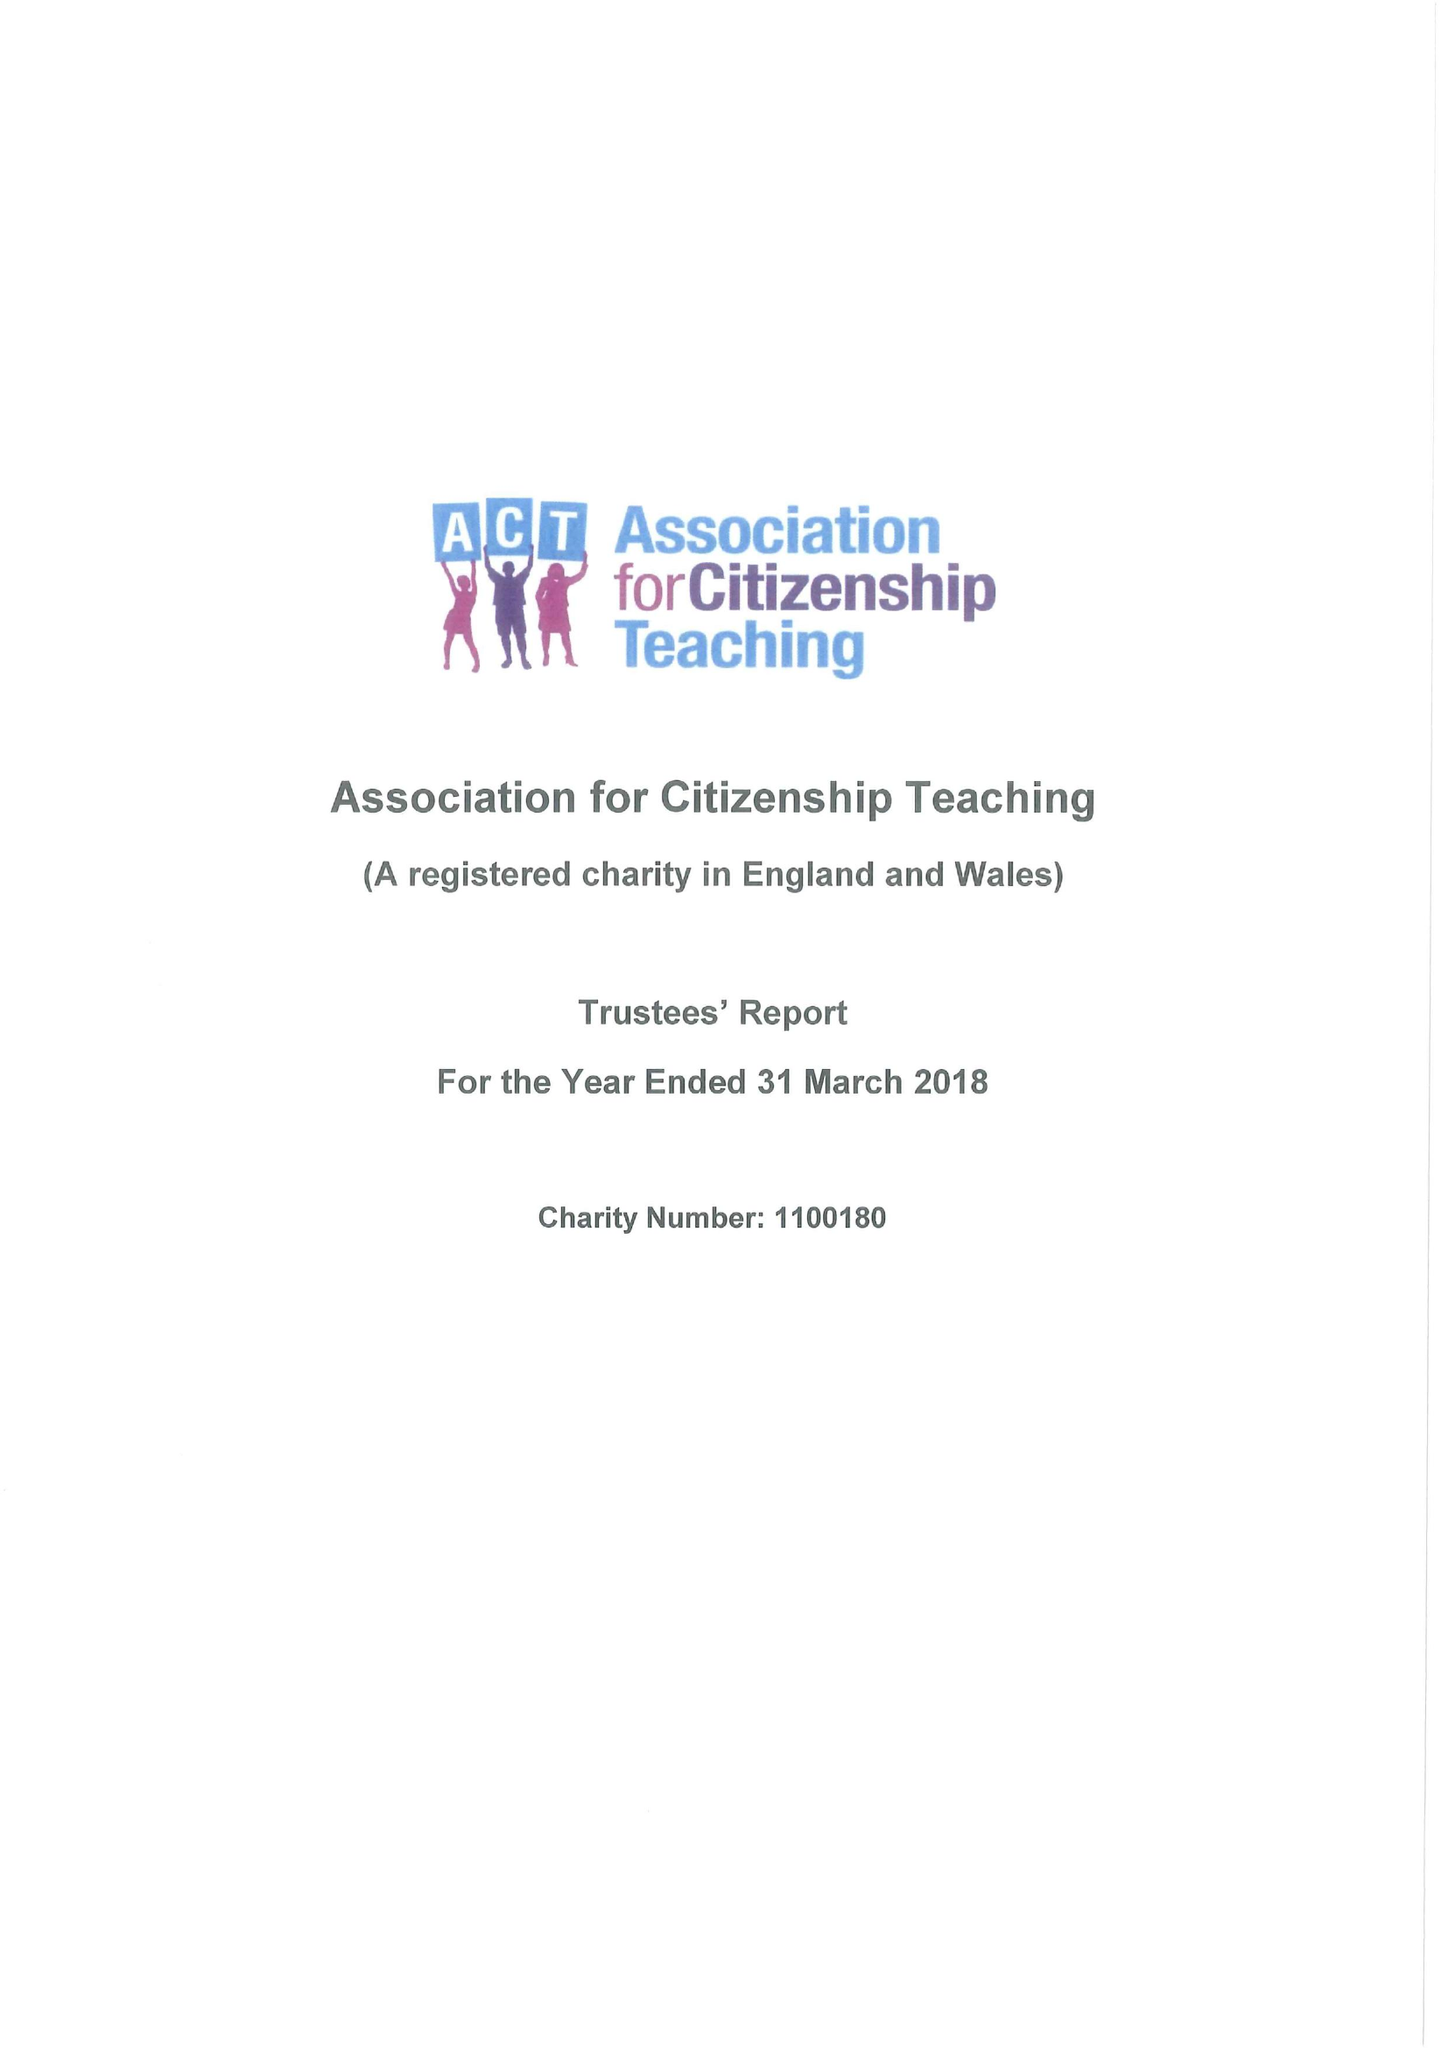What is the value for the address__postcode?
Answer the question using a single word or phrase. SW1P 2PD 